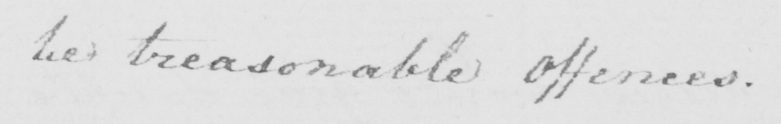Can you tell me what this handwritten text says? be treasonable Offences . 